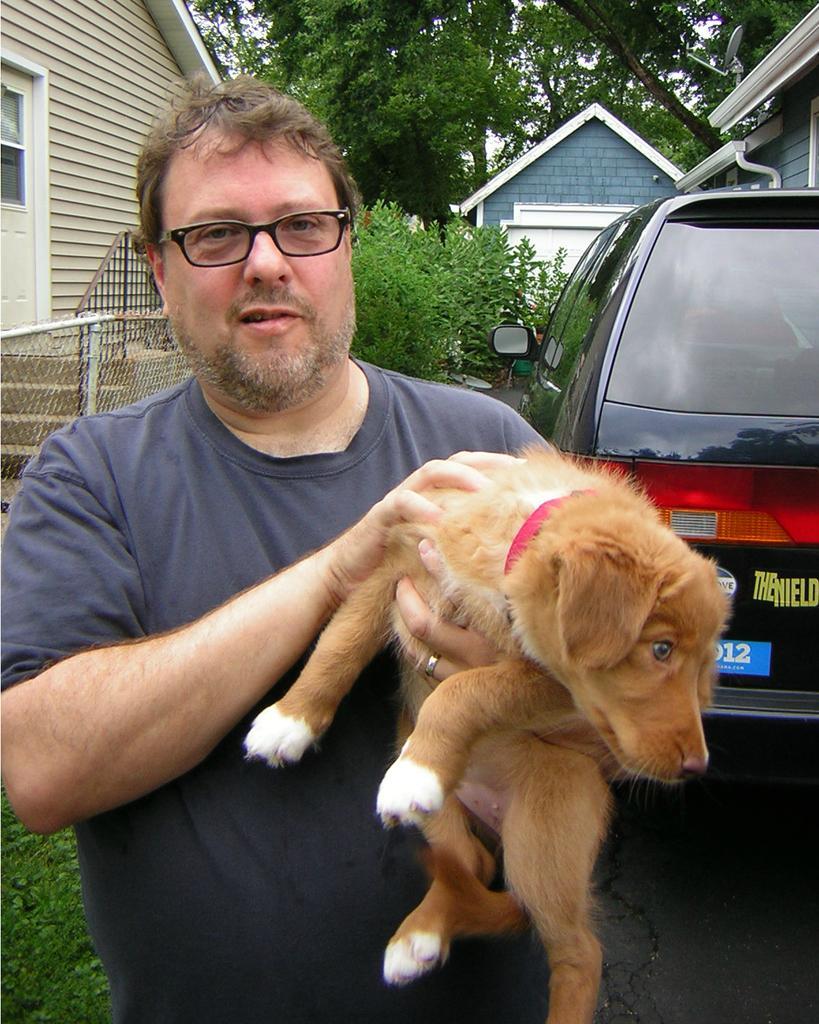How would you summarize this image in a sentence or two? This image is clicked outside. In this image there is a man, holding a dog. He is wearing a blue shirt. To the right, there is a car in black color. To the left, there is a house. In the background, there are trees and plants. 